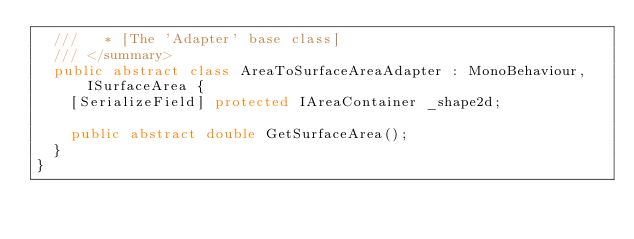Convert code to text. <code><loc_0><loc_0><loc_500><loc_500><_C#_>  ///   * [The 'Adapter' base class]
  /// </summary>
  public abstract class AreaToSurfaceAreaAdapter : MonoBehaviour, ISurfaceArea {
    [SerializeField] protected IAreaContainer _shape2d;

    public abstract double GetSurfaceArea();
  }
}</code> 